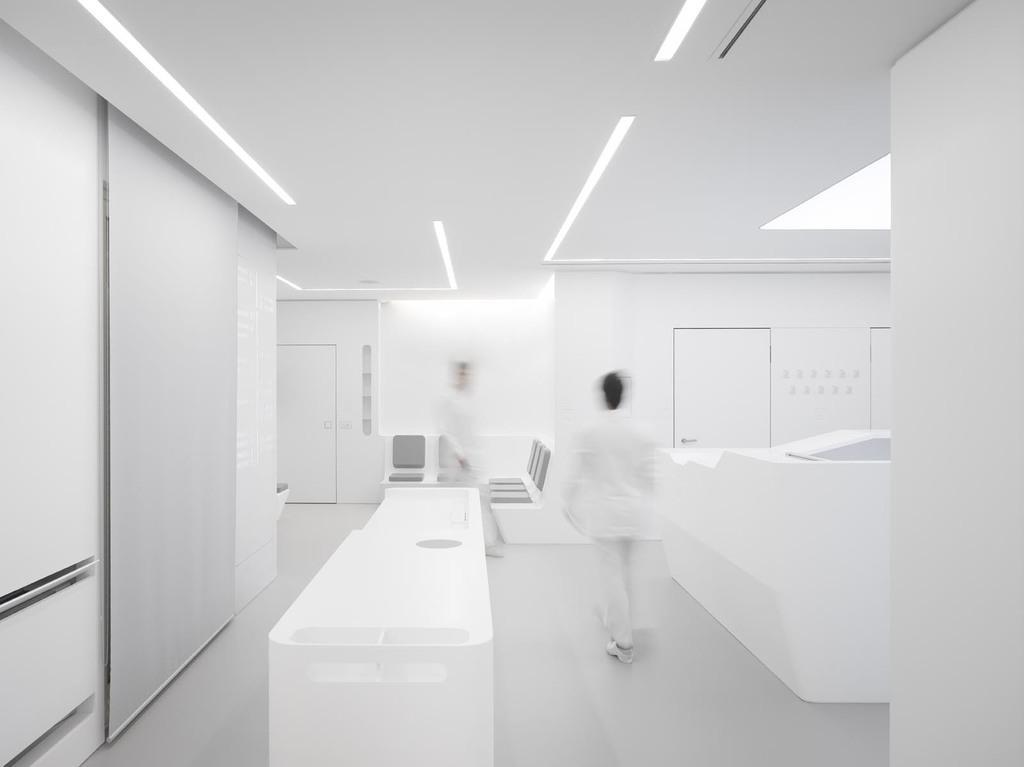Describe this image in one or two sentences. In this image we can see two persons on the floor, there are some doors, chairs, table, wall and some other objects, at the top we can see some lights. 